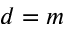<formula> <loc_0><loc_0><loc_500><loc_500>d = m</formula> 